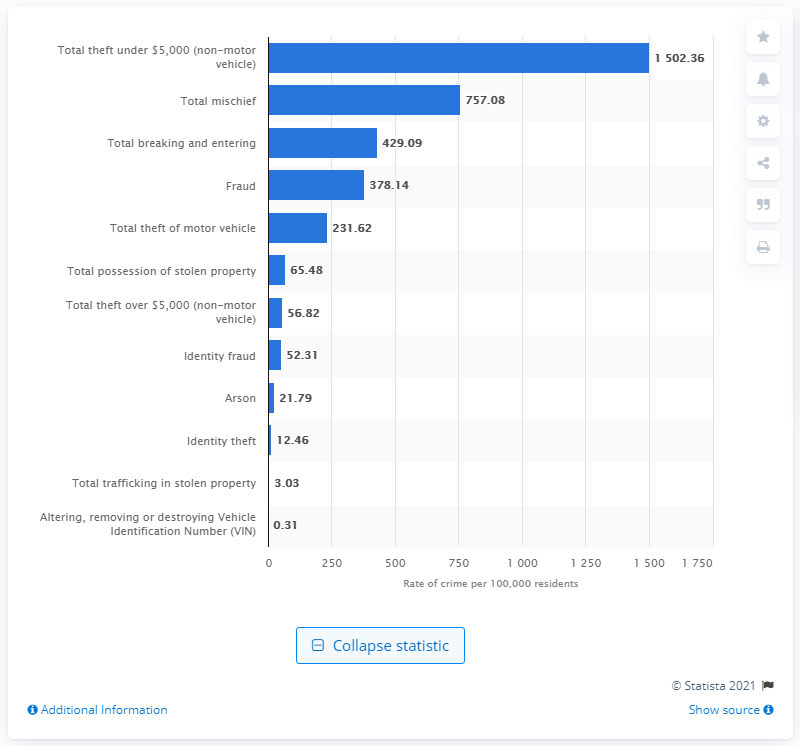How many incidents of mischief were reported per 100,000 residents in Canada in 2019? In 2019, there were 757.08 reported incidents of mischief for every 100,000 residents in Canada. This statistic reflects the rate at which such offenses were officially recorded, offering insight into the prevalence of mischief-related behavior within Canadian communities that year. 